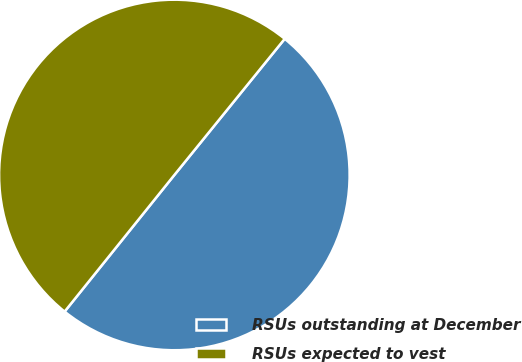Convert chart to OTSL. <chart><loc_0><loc_0><loc_500><loc_500><pie_chart><fcel>RSUs outstanding at December<fcel>RSUs expected to vest<nl><fcel>49.93%<fcel>50.07%<nl></chart> 